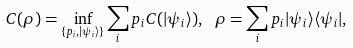<formula> <loc_0><loc_0><loc_500><loc_500>C ( \rho ) = \inf _ { \{ p _ { i } , | \psi _ { i } \rangle \} } \sum _ { i } p _ { i } C ( | \psi _ { i } \rangle ) , \ \rho = \sum _ { i } p _ { i } | \psi _ { i } \rangle \langle \psi _ { i } | ,</formula> 